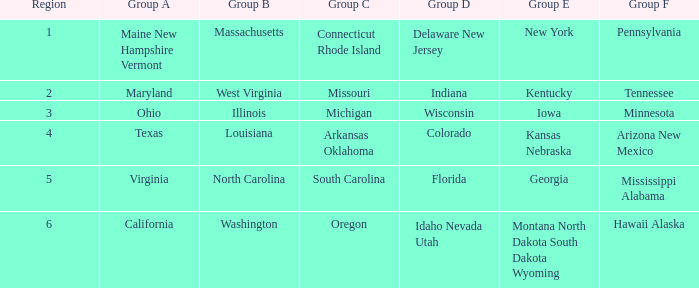What is the group B region with a Group E region of Georgia? North Carolina. 